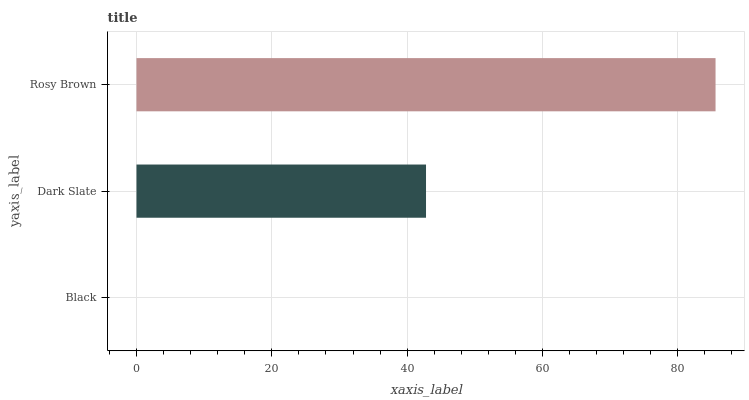Is Black the minimum?
Answer yes or no. Yes. Is Rosy Brown the maximum?
Answer yes or no. Yes. Is Dark Slate the minimum?
Answer yes or no. No. Is Dark Slate the maximum?
Answer yes or no. No. Is Dark Slate greater than Black?
Answer yes or no. Yes. Is Black less than Dark Slate?
Answer yes or no. Yes. Is Black greater than Dark Slate?
Answer yes or no. No. Is Dark Slate less than Black?
Answer yes or no. No. Is Dark Slate the high median?
Answer yes or no. Yes. Is Dark Slate the low median?
Answer yes or no. Yes. Is Black the high median?
Answer yes or no. No. Is Black the low median?
Answer yes or no. No. 